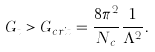<formula> <loc_0><loc_0><loc_500><loc_500>G _ { t } > G _ { c r i t } = \frac { 8 \pi ^ { 2 } } { N _ { c } } \frac { 1 } { \Lambda ^ { 2 } } .</formula> 